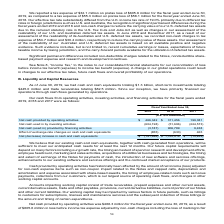According to Atlassian Plc's financial document, As of June 30, 2019, what is the amount of cash and cash equivalents? According to the financial document, $1.3 billion. The relevant text states: "0, 2019, we had cash and cash equivalents totaling $1.3 billion, short-term investments totaling..." Also, As of June 30, 2019, what is the amount of trade receivables? According to the financial document, $82.5 million. The relevant text states: "$445.0 million and trade receivables totaling $82.5 million. Since our inception, we have primarily financed our operations through cash flows generated by ope..." Also, What is the net cash used in investing activities in fiscal year ended 2019? According to the financial document, (604,198) (in thousands). The relevant text states: "Net cash used in by investing activities (604,198) (51,696) (224,573)..." Also, can you calculate: What is the difference in net cash provided by operating activities between fiscal year ended 2018 and 2019? Based on the calculation: 466,342-311,456, the result is 154886 (in thousands). This is based on the information: "Net cash provided by operating activities $ 466,342 $ 311,456 199,381 cash provided by operating activities $ 466,342 $ 311,456 199,381..." The key data points involved are: 311,456, 466,342. Also, can you calculate: What is the average net cash used in by investing activities for fiscal years 2017-2019? To answer this question, I need to perform calculations using the financial data. The calculation is: -(604,198+51,696+224,573)/3, which equals -293489 (in thousands). This is based on the information: "Net cash used in by investing activities (604,198) (51,696) (224,573) ed in by investing activities (604,198) (51,696) (224,573) t cash used in by investing activities (604,198) (51,696) (224,573)..." The key data points involved are: 224,573, 51,696, 604,198. Also, can you calculate: What is the percentage change of net cash provided by operating activities between fiscal year 2017 to 2018? To answer this question, I need to perform calculations using the financial data. The calculation is: (311,456-199,381)/199,381, which equals 56.21 (percentage). This is based on the information: "cash provided by operating activities $ 466,342 $ 311,456 199,381 vided by operating activities $ 466,342 $ 311,456 199,381..." The key data points involved are: 199,381, 311,456. 